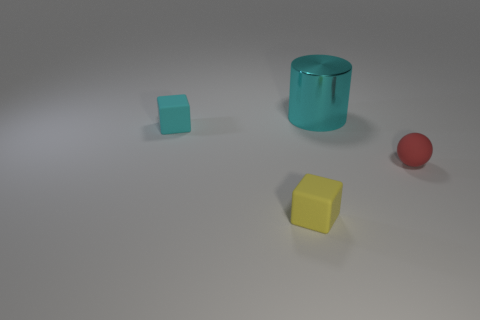Add 4 tiny purple matte balls. How many objects exist? 8 Subtract all cylinders. How many objects are left? 3 Add 1 big cyan cylinders. How many big cyan cylinders are left? 2 Add 1 large gray shiny blocks. How many large gray shiny blocks exist? 1 Subtract 1 cyan cubes. How many objects are left? 3 Subtract all tiny red rubber balls. Subtract all small red things. How many objects are left? 2 